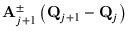Convert formula to latex. <formula><loc_0><loc_0><loc_500><loc_500>A _ { j + 1 } ^ { \pm } \left ( Q _ { j + 1 } - Q _ { j } \right )</formula> 